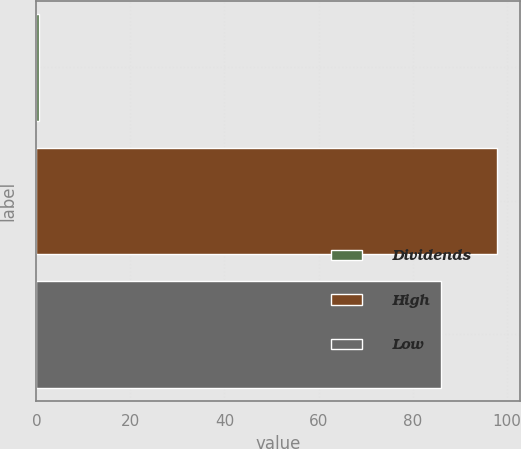Convert chart. <chart><loc_0><loc_0><loc_500><loc_500><bar_chart><fcel>Dividends<fcel>High<fcel>Low<nl><fcel>0.55<fcel>98<fcel>86.01<nl></chart> 